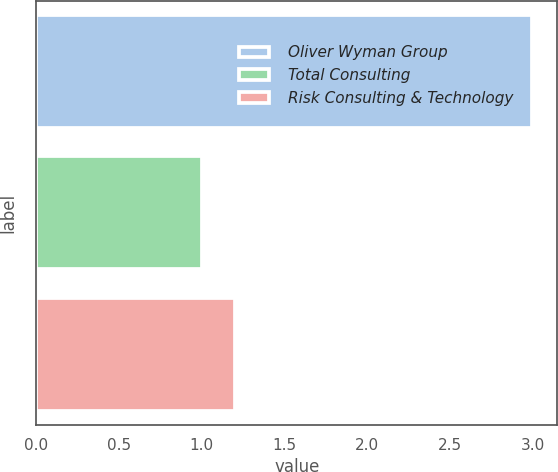<chart> <loc_0><loc_0><loc_500><loc_500><bar_chart><fcel>Oliver Wyman Group<fcel>Total Consulting<fcel>Risk Consulting & Technology<nl><fcel>3<fcel>1<fcel>1.2<nl></chart> 